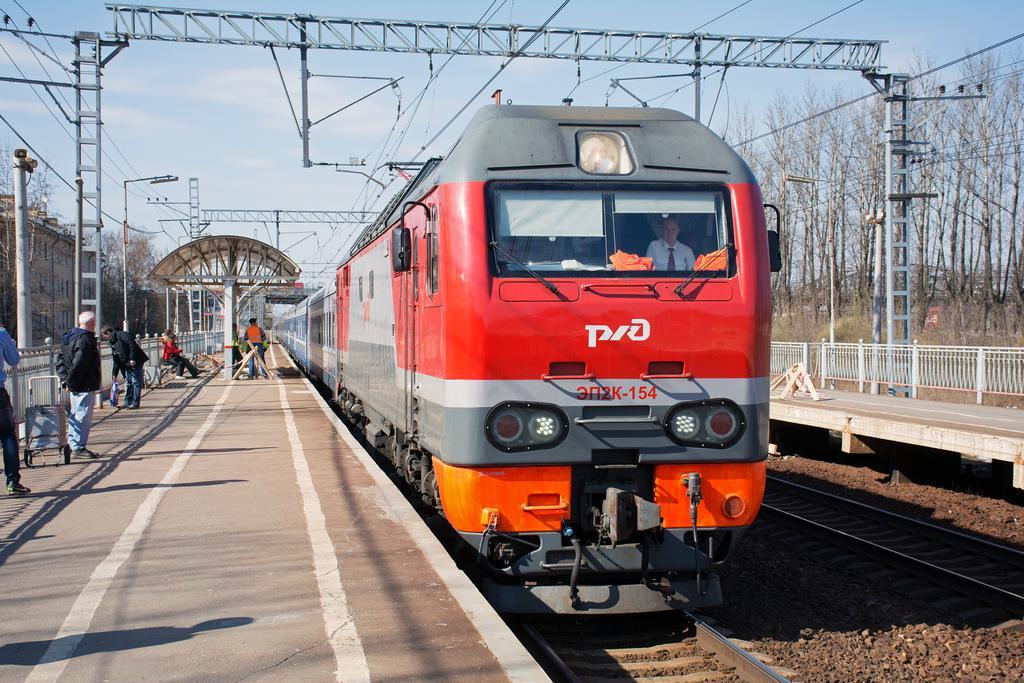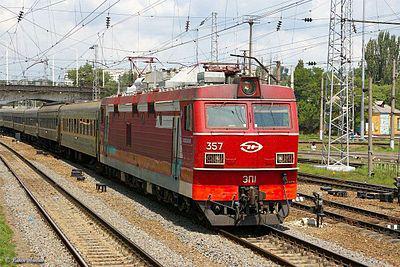The first image is the image on the left, the second image is the image on the right. Given the left and right images, does the statement "All trains are facing the same direction." hold true? Answer yes or no. Yes. The first image is the image on the left, the second image is the image on the right. For the images shown, is this caption "All trains have a reddish front, and no image shows the front of more than one train." true? Answer yes or no. Yes. 